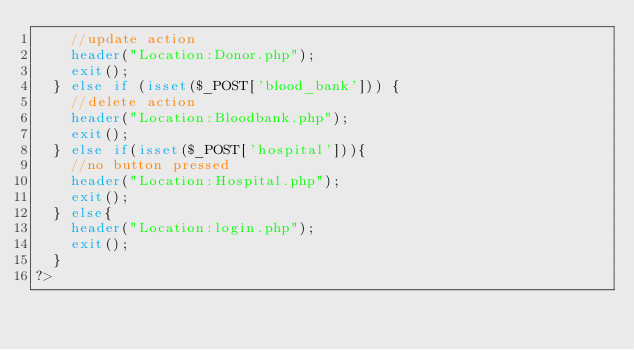<code> <loc_0><loc_0><loc_500><loc_500><_PHP_>    //update action
		header("Location:Donor.php");
		exit();
	} else if (isset($_POST['blood_bank'])) {
    //delete action
		header("Location:Bloodbank.php");
		exit();
	} else if(isset($_POST['hospital'])){
    //no button pressed
		header("Location:Hospital.php");
		exit();
	} else{
		header("Location:login.php");
		exit();
	}
?></code> 